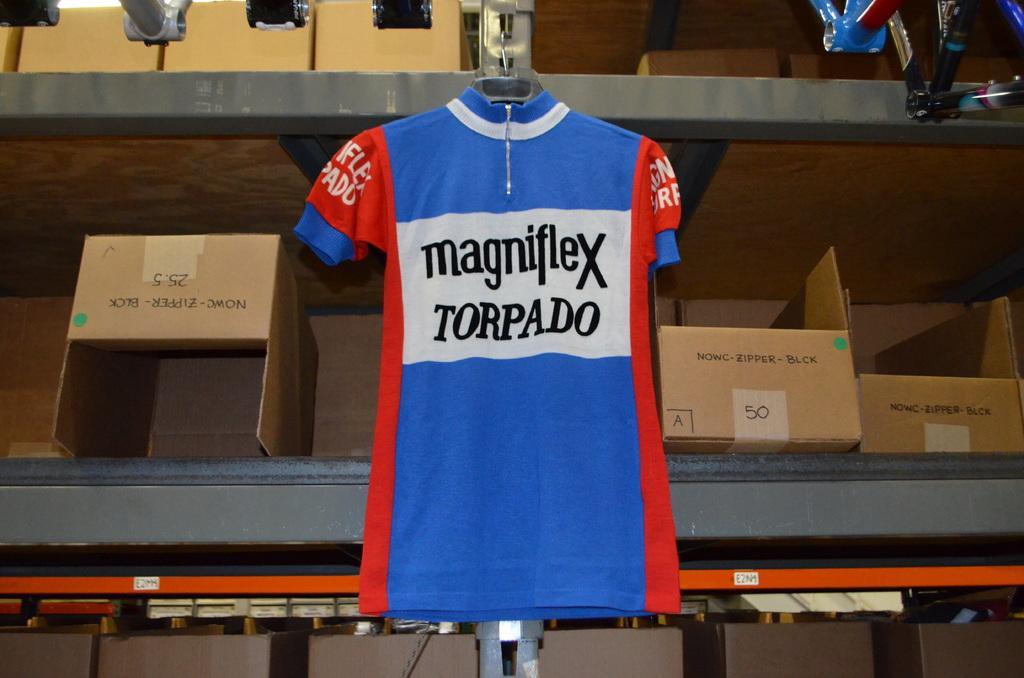How would you summarize this image in a sentence or two? In this image I can see a t shirt which is blue, white and red in color is changed to a rack. I can see few cardboard boxes in the rack which are brown in color and the rack is grey in color. 